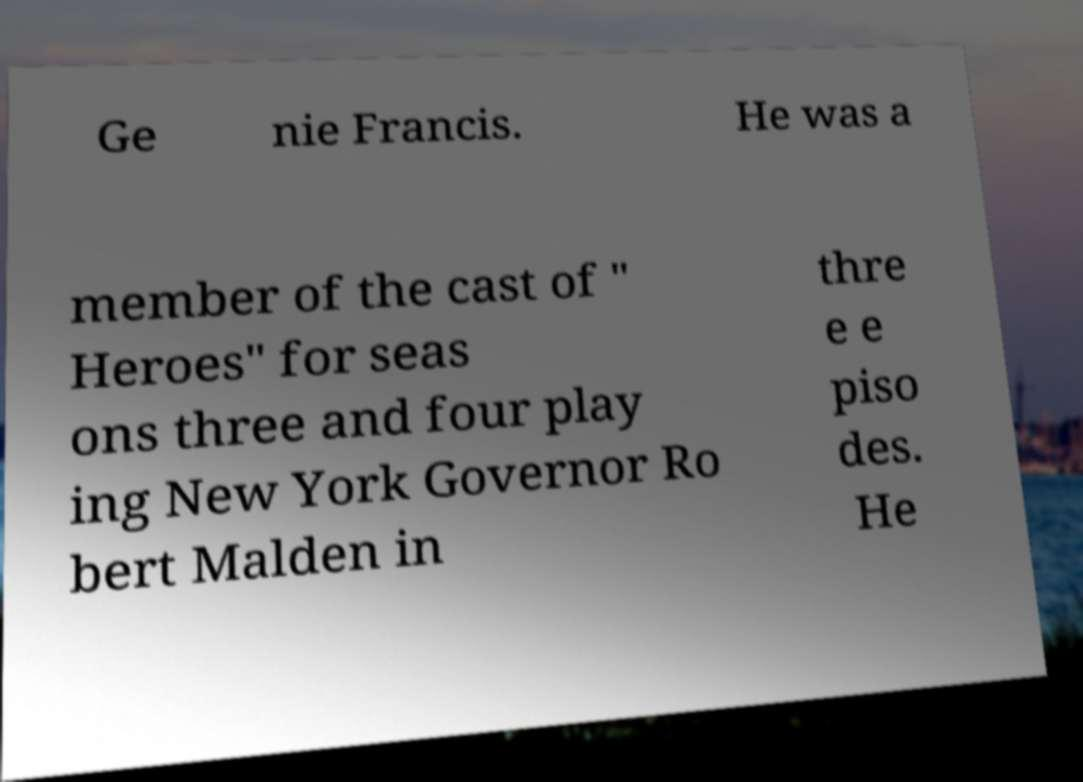What messages or text are displayed in this image? I need them in a readable, typed format. Ge nie Francis. He was a member of the cast of " Heroes" for seas ons three and four play ing New York Governor Ro bert Malden in thre e e piso des. He 